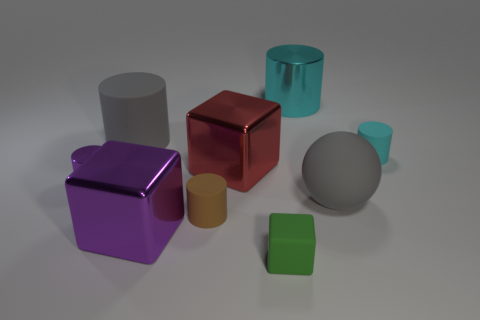Subtract all large cyan metallic cylinders. How many cylinders are left? 4 Subtract all gray cylinders. How many cylinders are left? 4 Subtract all blue cylinders. Subtract all red cubes. How many cylinders are left? 5 Subtract all spheres. How many objects are left? 8 Subtract all purple cylinders. Subtract all green rubber objects. How many objects are left? 7 Add 9 large cyan cylinders. How many large cyan cylinders are left? 10 Add 4 brown matte cubes. How many brown matte cubes exist? 4 Subtract 0 blue balls. How many objects are left? 9 